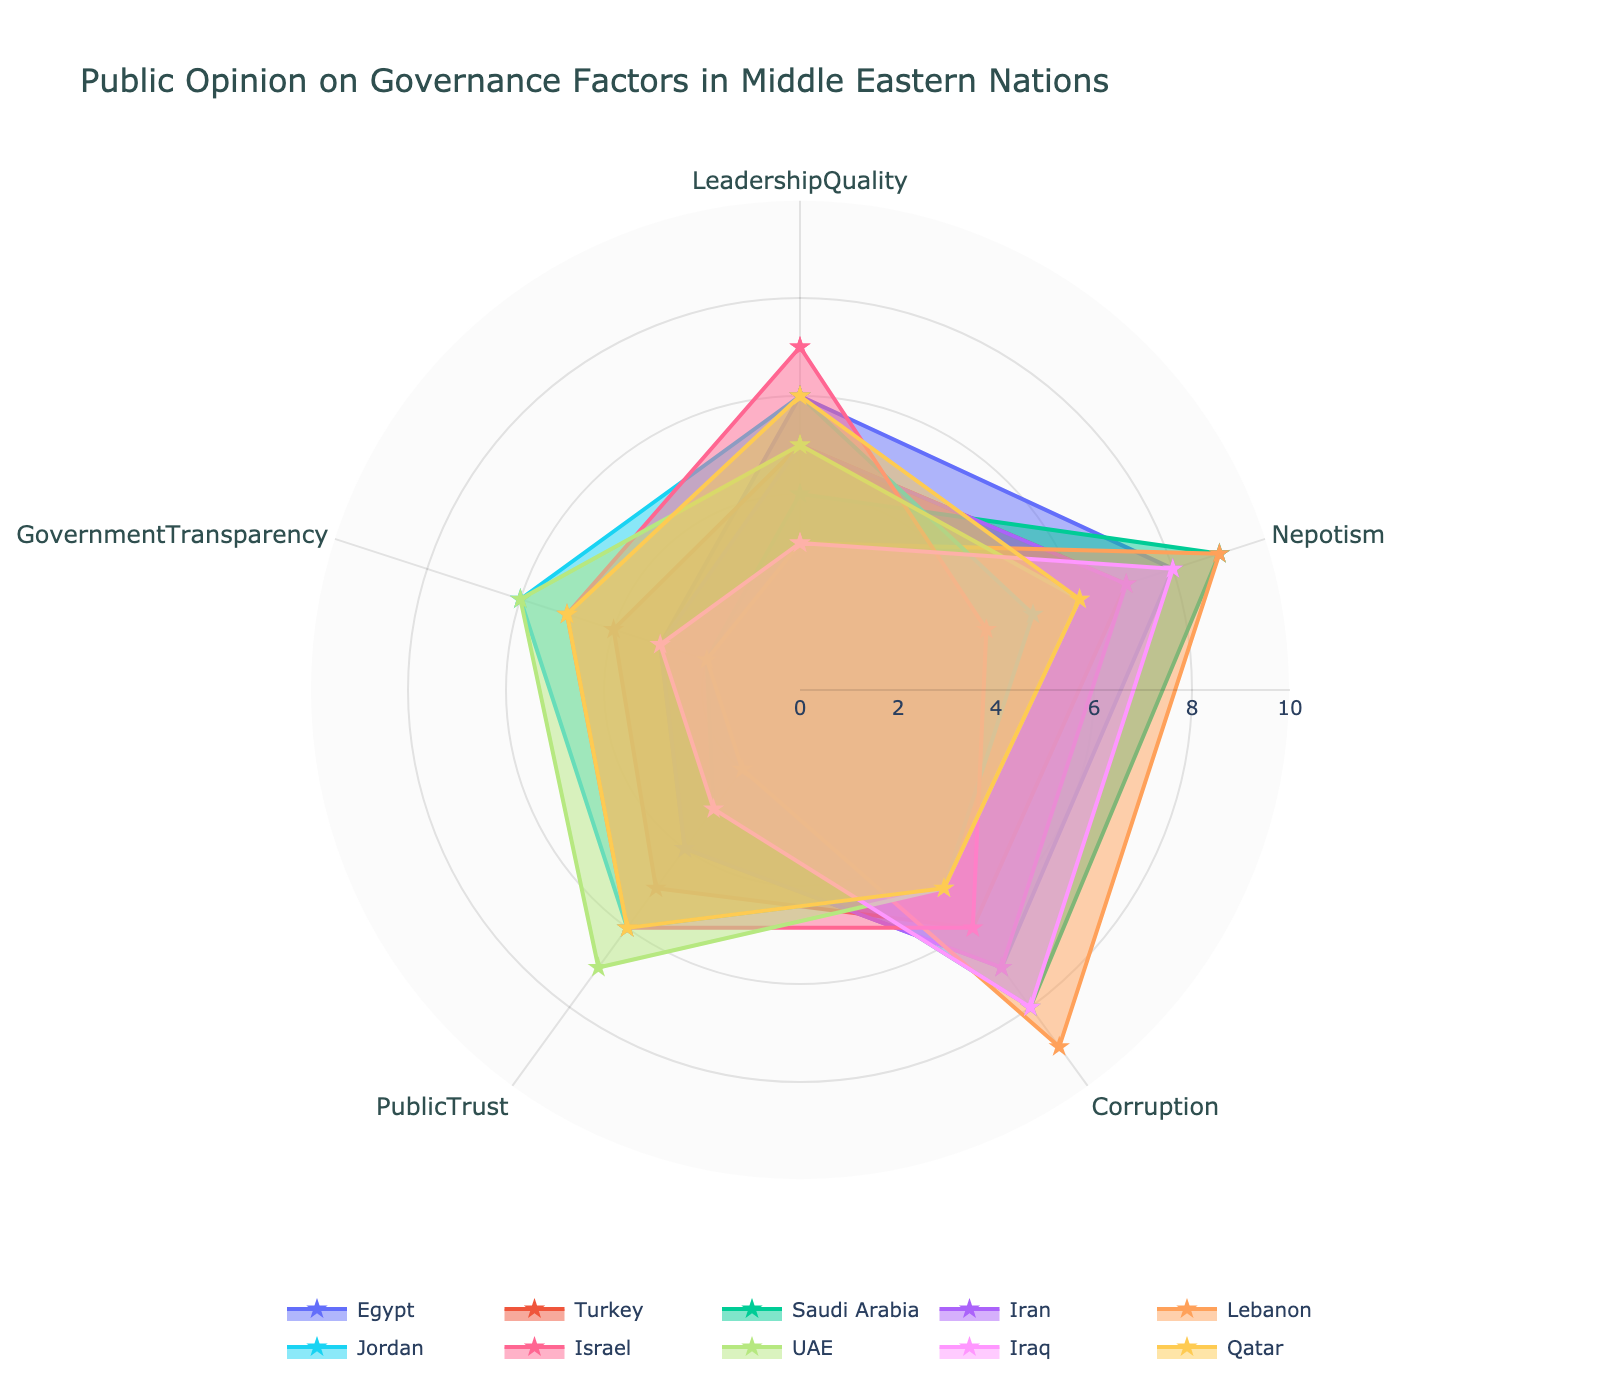what is the title of the chart? The title of the chart is located at the top and in larger font, indicating the focus of the visual representation.
Answer: Public Opinion on Governance Factors in Middle Eastern Nations Which country has the highest score for nepotism? By scanning the radar chart for the highest peak in the 'Nepotism' axis, we identify the country with the highest value.
Answer: Saudi Arabia and Lebanon How do Leadership Quality and Nepotism compare for Israel? By examining the plot for Israel, we check the values on both the 'Leadership Quality' and 'Nepotism' axes and note their respective positions.
Answer: Leadership Quality is 7 and Nepotism is 4 Which country scores the lowest in Government Transparency? By looking at the 'Government Transparency' axis and finding the smallest value on the radar chart, the corresponding country can be identified.
Answer: Saudi Arabia and Lebanon What is the average score of leadership quality across all countries? Summing the Leadership Quality values from all countries and dividing by the number of countries (10) gives the average Leadership Quality score.
Answer: (6+5+4+5+3+6+7+5+3+6) / 10 = 5 Which countries have a higher score for Public Trust than Corruption? Comparing the scores for Public Trust and Corruption for each country in the radar chart will reveal which countries have greater values for Public Trust.
Answer: Jordan, UAE, Qatar How does Jordan's score in Public Trust compare to that of Lebanon? Referring to the 'Public Trust' scores on the radar chart for both Jordan and Lebanon, we determine which is higher.
Answer: Jordan's score is higher (6 compared to 2) Which country has the most balanced scores across all governance factors? By visually inspecting the radar chart for each country and looking for a plot with similar lengths of radii in all four directions, we determine the country's balance in scores.
Answer: Qatar What is the range of scores for Corruption among all the countries? The highest and lowest values seen for 'Corruption' across the radar chart are noted to determine the range.
Answer: Range is 9 - 5 = 4 What is the most common score for Nepotism? Identifying the frequency of each score on the 'Nepotism' axis across countries helps in determining the most common score.
Answer: 6 and 8 